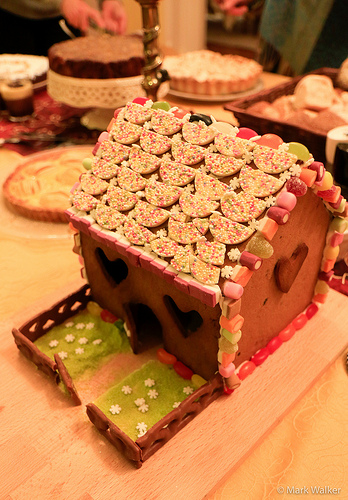<image>
Is the pie behind the bread? Yes. From this viewpoint, the pie is positioned behind the bread, with the bread partially or fully occluding the pie. 